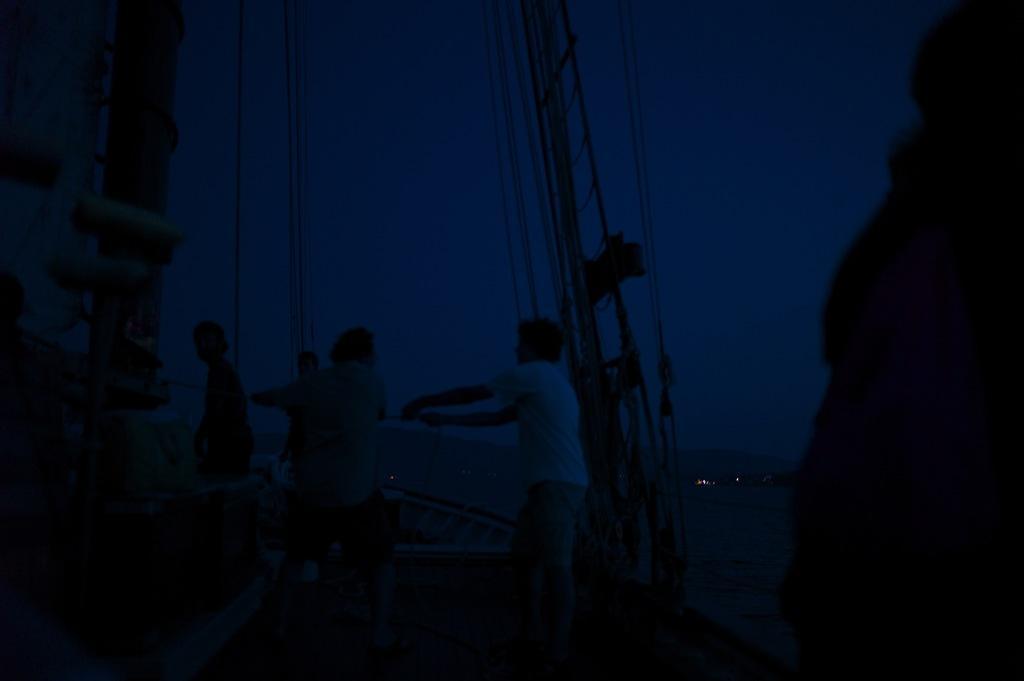Could you give a brief overview of what you see in this image? In this image, in the middle, we can see three people. In the middle, we can also see a metal instrument. On the right side and left side, we can see black color. In the background, we can see some lights and black color. 